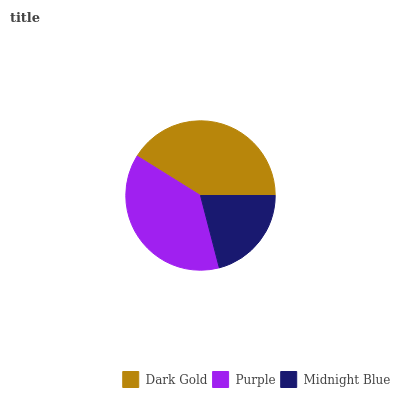Is Midnight Blue the minimum?
Answer yes or no. Yes. Is Dark Gold the maximum?
Answer yes or no. Yes. Is Purple the minimum?
Answer yes or no. No. Is Purple the maximum?
Answer yes or no. No. Is Dark Gold greater than Purple?
Answer yes or no. Yes. Is Purple less than Dark Gold?
Answer yes or no. Yes. Is Purple greater than Dark Gold?
Answer yes or no. No. Is Dark Gold less than Purple?
Answer yes or no. No. Is Purple the high median?
Answer yes or no. Yes. Is Purple the low median?
Answer yes or no. Yes. Is Midnight Blue the high median?
Answer yes or no. No. Is Dark Gold the low median?
Answer yes or no. No. 